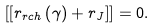Convert formula to latex. <formula><loc_0><loc_0><loc_500><loc_500>\left [ \left [ r _ { r c h } \left ( \gamma \right ) + r _ { J } \right ] \right ] = 0 .</formula> 